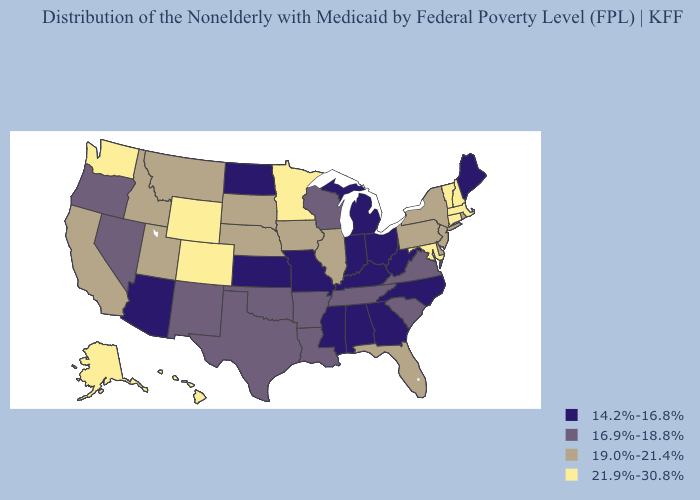What is the value of New Mexico?
Concise answer only. 16.9%-18.8%. Name the states that have a value in the range 19.0%-21.4%?
Be succinct. California, Delaware, Florida, Idaho, Illinois, Iowa, Montana, Nebraska, New Jersey, New York, Pennsylvania, Rhode Island, South Dakota, Utah. What is the lowest value in the USA?
Give a very brief answer. 14.2%-16.8%. What is the lowest value in the South?
Quick response, please. 14.2%-16.8%. Name the states that have a value in the range 14.2%-16.8%?
Answer briefly. Alabama, Arizona, Georgia, Indiana, Kansas, Kentucky, Maine, Michigan, Mississippi, Missouri, North Carolina, North Dakota, Ohio, West Virginia. Name the states that have a value in the range 16.9%-18.8%?
Concise answer only. Arkansas, Louisiana, Nevada, New Mexico, Oklahoma, Oregon, South Carolina, Tennessee, Texas, Virginia, Wisconsin. Which states have the lowest value in the USA?
Answer briefly. Alabama, Arizona, Georgia, Indiana, Kansas, Kentucky, Maine, Michigan, Mississippi, Missouri, North Carolina, North Dakota, Ohio, West Virginia. Among the states that border Wyoming , does Colorado have the lowest value?
Answer briefly. No. Does Massachusetts have the highest value in the Northeast?
Quick response, please. Yes. Name the states that have a value in the range 14.2%-16.8%?
Give a very brief answer. Alabama, Arizona, Georgia, Indiana, Kansas, Kentucky, Maine, Michigan, Mississippi, Missouri, North Carolina, North Dakota, Ohio, West Virginia. Does Rhode Island have the lowest value in the USA?
Write a very short answer. No. What is the value of North Dakota?
Be succinct. 14.2%-16.8%. Among the states that border Indiana , which have the highest value?
Concise answer only. Illinois. What is the value of Washington?
Give a very brief answer. 21.9%-30.8%. What is the highest value in states that border New York?
Give a very brief answer. 21.9%-30.8%. 